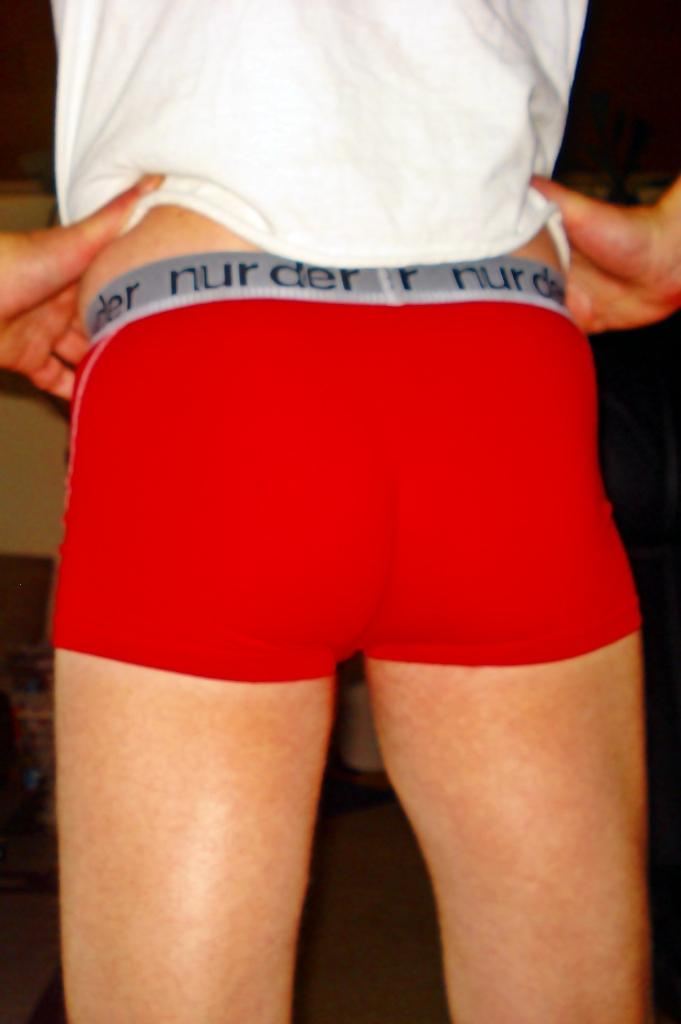<image>
Present a compact description of the photo's key features. A pair of underwear type shorts that say nur der on the waistband. 